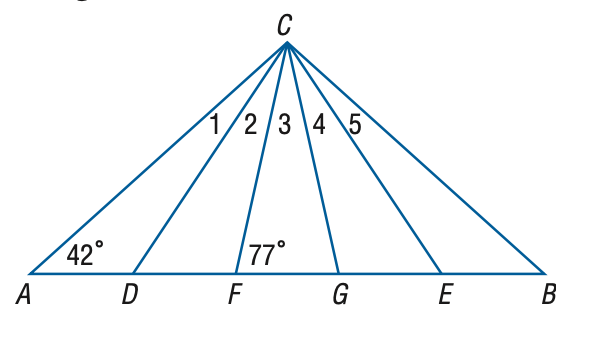Answer the mathemtical geometry problem and directly provide the correct option letter.
Question: In the figure, \triangle A B C is isosceles, \triangle D C E is equilateral, and \triangle F C G is isosceles. Find the measure of the \angle 3 at vertex C.
Choices: A: 22 B: 26 C: 27 D: 28 B 